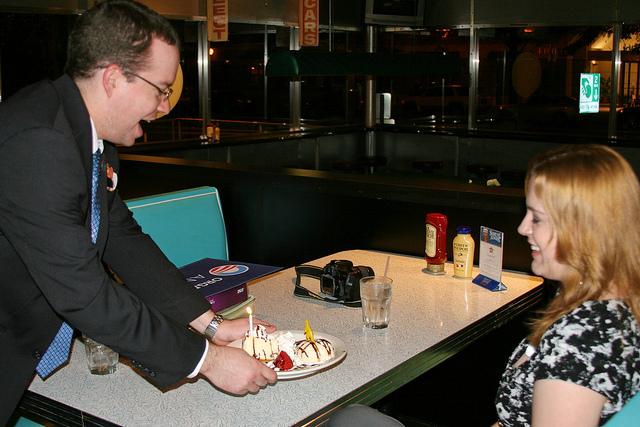How many candles are in this image?
Answer briefly. 1. What is the woman drinking?
Give a very brief answer. Water. Are they a couple?
Be succinct. Yes. What is in her glass?
Short answer required. Water. 